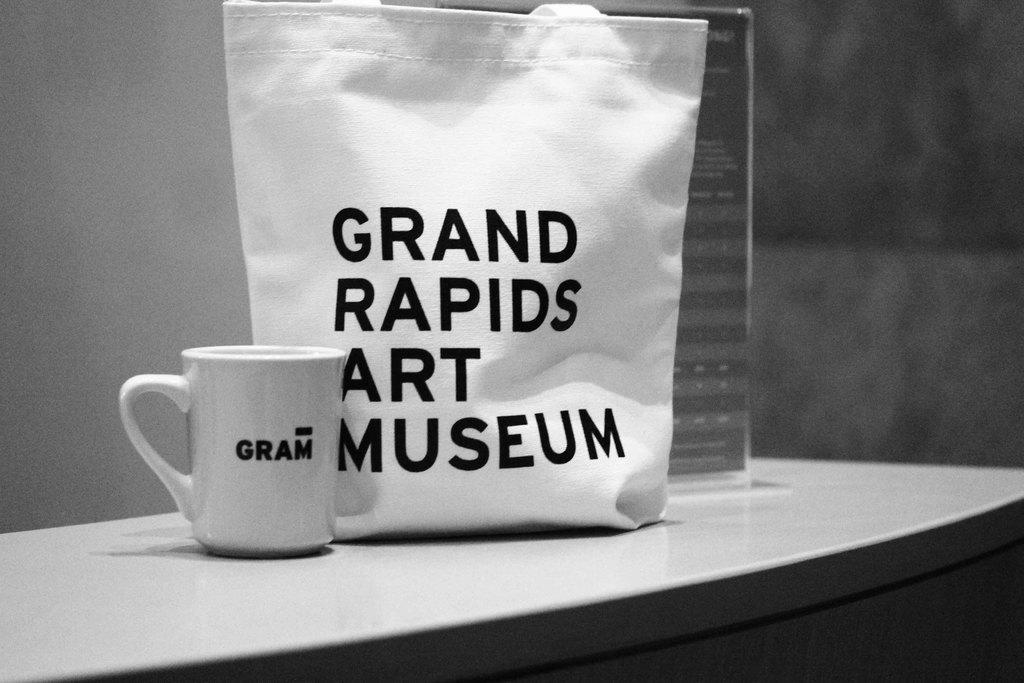What is the color scheme of the image? The image is black and white. What object can be seen in the image? There is a bag in the image. What is the color of the cup in the image? The cup is white-colored in the image. Where is the cup located in the image? The cup is on a table in the image. What level of learning is the bag at in the image? The bag is an inanimate object and does not have a level of learning. 